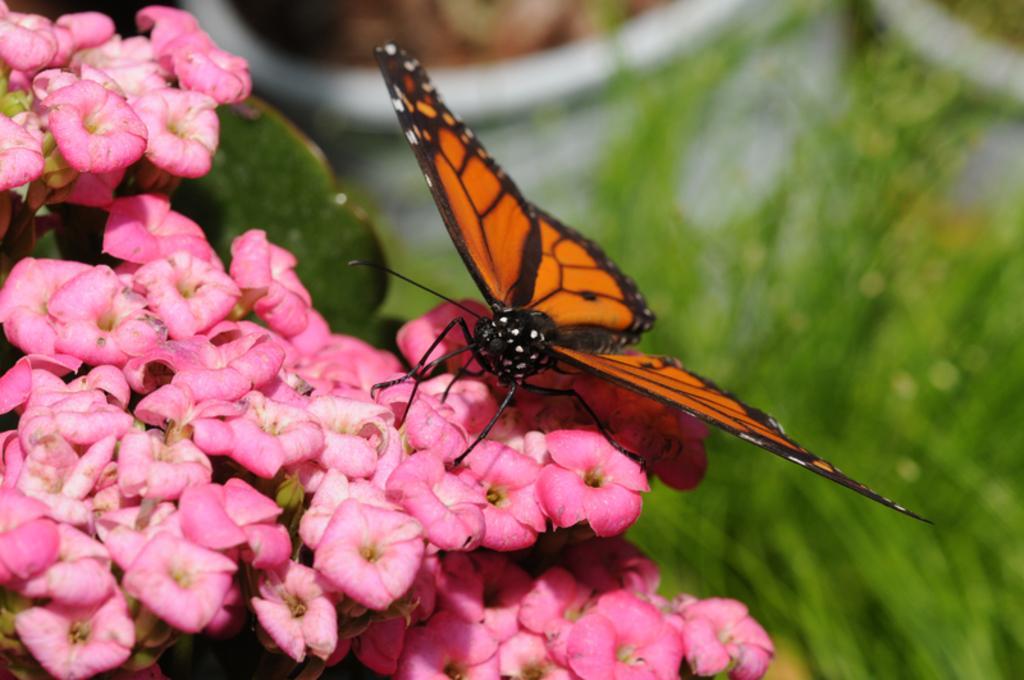Can you describe this image briefly? In this image, we can see a butterfly is on the flowers. Here we can see so many flowers, leaves. Background there is a blur view. Here we can see white, brown and green colors. 